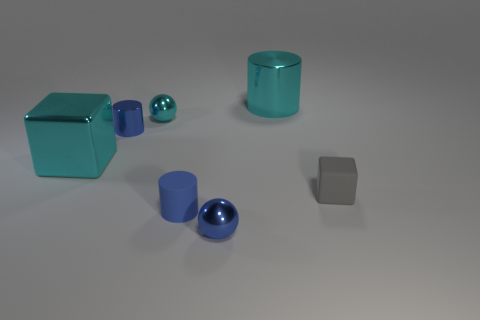Subtract all cyan metallic cylinders. How many cylinders are left? 2 Add 2 small blue metal things. How many objects exist? 9 Subtract all cyan spheres. How many spheres are left? 1 Subtract all cylinders. How many objects are left? 4 Subtract 1 cubes. How many cubes are left? 1 Subtract all green spheres. Subtract all brown cubes. How many spheres are left? 2 Add 5 small red rubber balls. How many small red rubber balls exist? 5 Subtract 1 blue balls. How many objects are left? 6 Subtract all blue spheres. How many red blocks are left? 0 Subtract all tiny blue metallic balls. Subtract all tiny things. How many objects are left? 1 